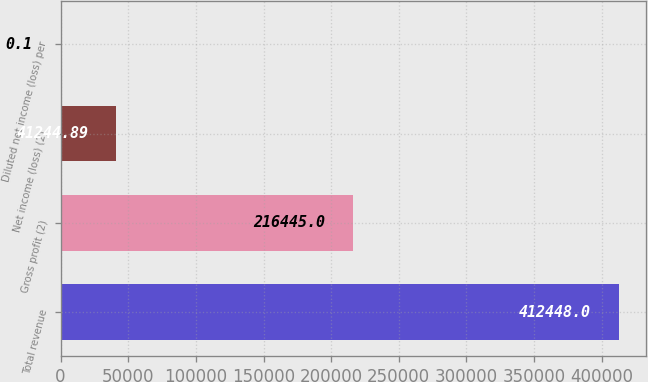<chart> <loc_0><loc_0><loc_500><loc_500><bar_chart><fcel>Total revenue<fcel>Gross profit (2)<fcel>Net income (loss) (2)<fcel>Diluted net income (loss) per<nl><fcel>412448<fcel>216445<fcel>41244.9<fcel>0.1<nl></chart> 